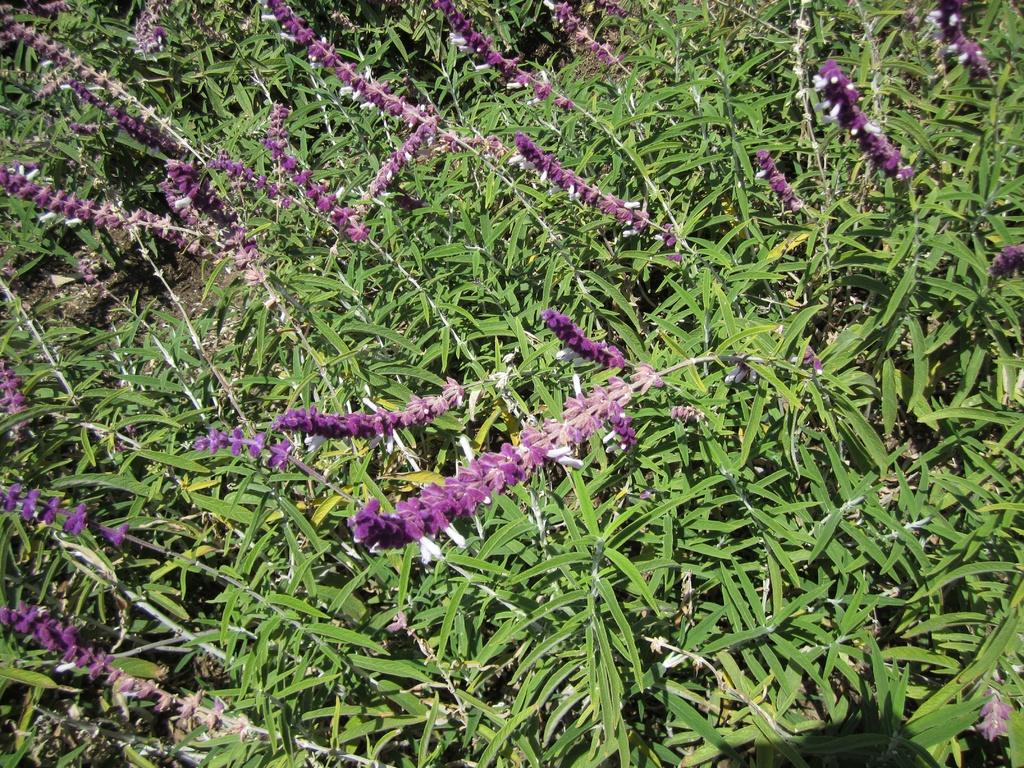What type of plant is visible in the image? There is a purple flower plant in the image. What is the plant growing in? The flower plant is grown in thick grass. What is the price of the knee in the image? There is no knee present in the image, so it is not possible to determine its price. 